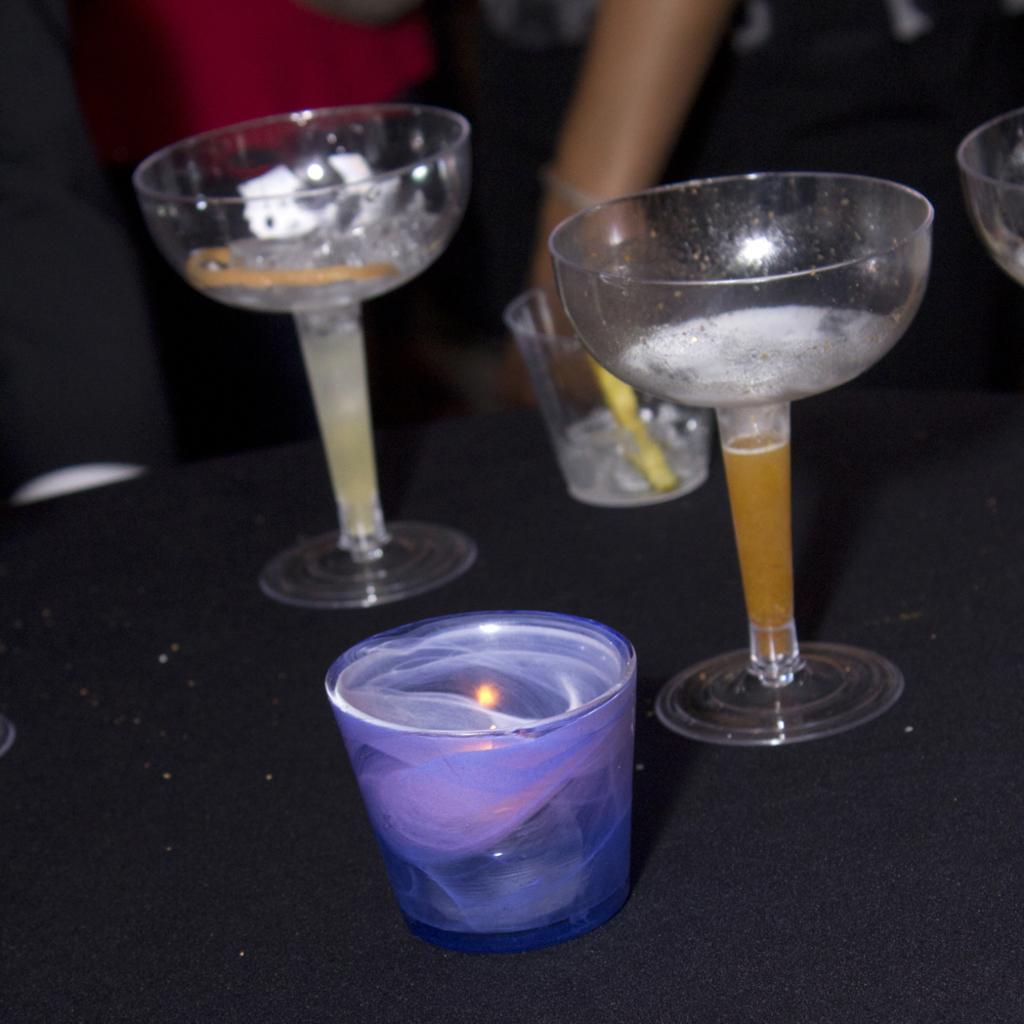What objects are on the table in the image? There are glasses on the table in the image. Can you describe any other elements in the image? Yes, there is a human hand visible in the image. How many buns are being held by the person in the image? There is no bun present in the image; only glasses and a human hand are visible. 